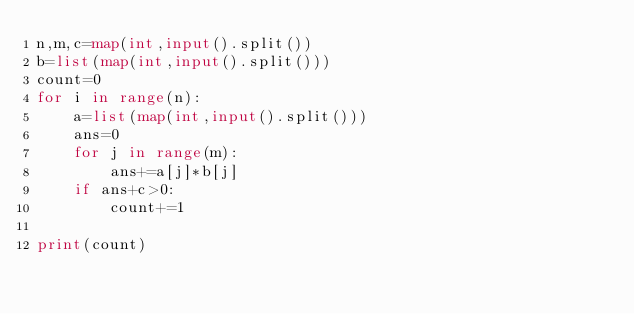<code> <loc_0><loc_0><loc_500><loc_500><_Python_>n,m,c=map(int,input().split())
b=list(map(int,input().split()))
count=0
for i in range(n):
    a=list(map(int,input().split()))
    ans=0
    for j in range(m):
        ans+=a[j]*b[j]
    if ans+c>0:
        count+=1
            
print(count)</code> 